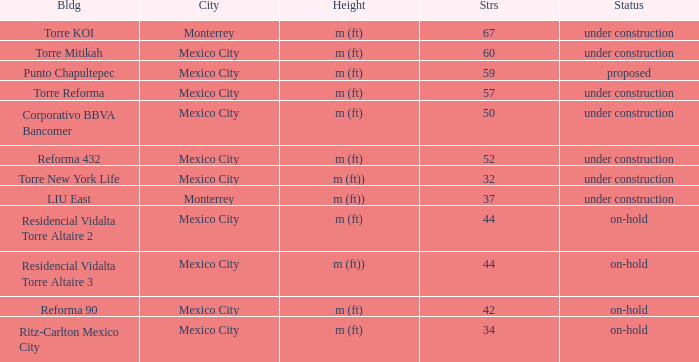How many stories is the torre reforma building? 1.0. 